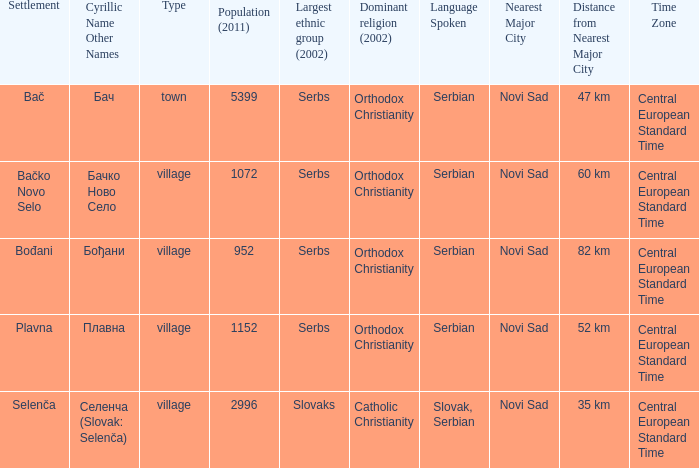What is the smallest population listed? 952.0. 